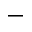<formula> <loc_0><loc_0><loc_500><loc_500>-</formula> 